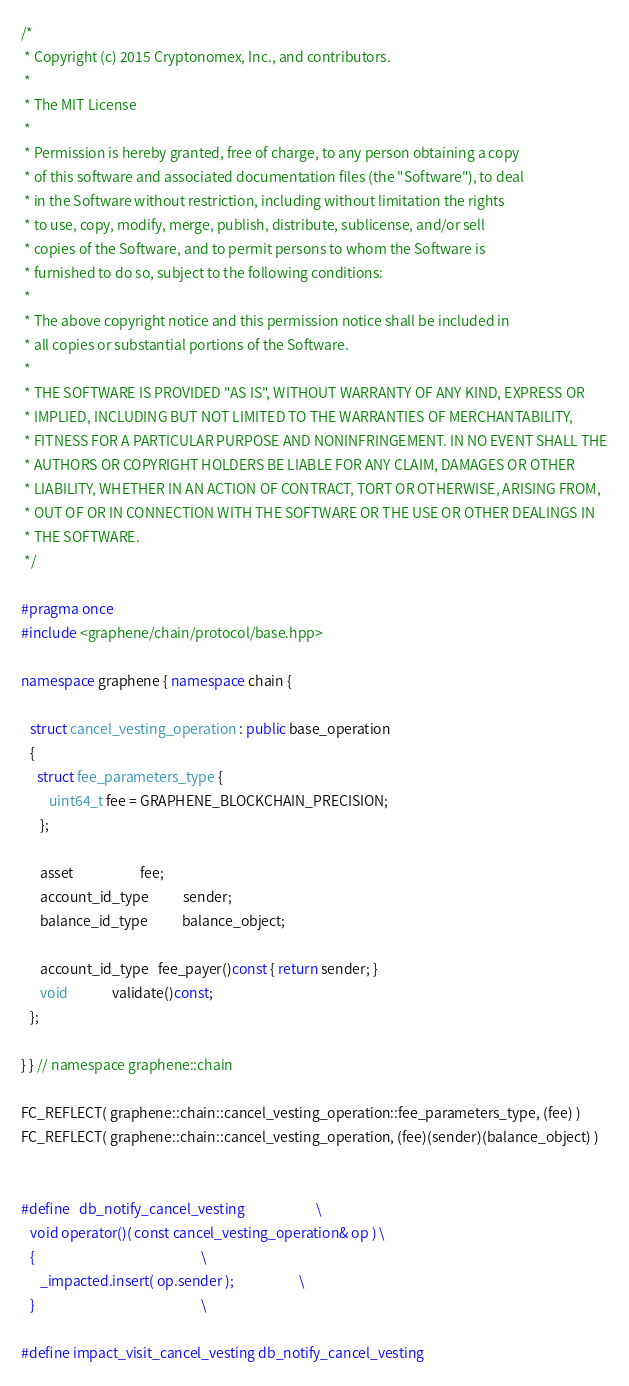Convert code to text. <code><loc_0><loc_0><loc_500><loc_500><_C++_>/*
 * Copyright (c) 2015 Cryptonomex, Inc., and contributors.
 *
 * The MIT License
 *
 * Permission is hereby granted, free of charge, to any person obtaining a copy
 * of this software and associated documentation files (the "Software"), to deal
 * in the Software without restriction, including without limitation the rights
 * to use, copy, modify, merge, publish, distribute, sublicense, and/or sell
 * copies of the Software, and to permit persons to whom the Software is
 * furnished to do so, subject to the following conditions:
 *
 * The above copyright notice and this permission notice shall be included in
 * all copies or substantial portions of the Software.
 *
 * THE SOFTWARE IS PROVIDED "AS IS", WITHOUT WARRANTY OF ANY KIND, EXPRESS OR
 * IMPLIED, INCLUDING BUT NOT LIMITED TO THE WARRANTIES OF MERCHANTABILITY,
 * FITNESS FOR A PARTICULAR PURPOSE AND NONINFRINGEMENT. IN NO EVENT SHALL THE
 * AUTHORS OR COPYRIGHT HOLDERS BE LIABLE FOR ANY CLAIM, DAMAGES OR OTHER
 * LIABILITY, WHETHER IN AN ACTION OF CONTRACT, TORT OR OTHERWISE, ARISING FROM,
 * OUT OF OR IN CONNECTION WITH THE SOFTWARE OR THE USE OR OTHER DEALINGS IN
 * THE SOFTWARE.
 */

#pragma once
#include <graphene/chain/protocol/base.hpp>

namespace graphene { namespace chain { 

   struct cancel_vesting_operation : public base_operation
   {
     struct fee_parameters_type { 
         uint64_t fee = GRAPHENE_BLOCKCHAIN_PRECISION; 
      };

      asset                     fee;
      account_id_type           sender;
      balance_id_type           balance_object;

      account_id_type   fee_payer()const { return sender; }
      void              validate()const;
   };

} } // namespace graphene::chain

FC_REFLECT( graphene::chain::cancel_vesting_operation::fee_parameters_type, (fee) )
FC_REFLECT( graphene::chain::cancel_vesting_operation, (fee)(sender)(balance_object) )


#define   db_notify_cancel_vesting                       \
   void operator()( const cancel_vesting_operation& op ) \
   {                                                     \
      _impacted.insert( op.sender );                     \
   }                                                     \

#define impact_visit_cancel_vesting db_notify_cancel_vesting   
</code> 